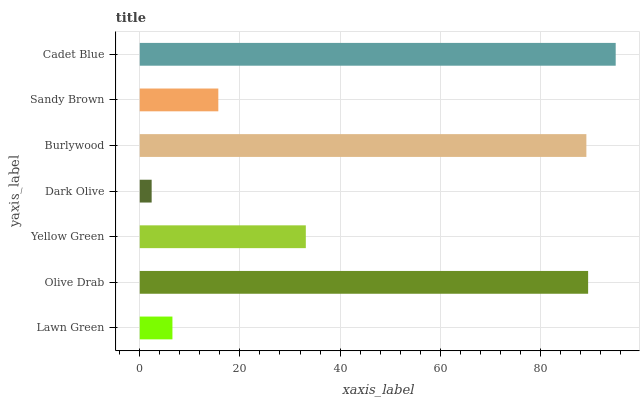Is Dark Olive the minimum?
Answer yes or no. Yes. Is Cadet Blue the maximum?
Answer yes or no. Yes. Is Olive Drab the minimum?
Answer yes or no. No. Is Olive Drab the maximum?
Answer yes or no. No. Is Olive Drab greater than Lawn Green?
Answer yes or no. Yes. Is Lawn Green less than Olive Drab?
Answer yes or no. Yes. Is Lawn Green greater than Olive Drab?
Answer yes or no. No. Is Olive Drab less than Lawn Green?
Answer yes or no. No. Is Yellow Green the high median?
Answer yes or no. Yes. Is Yellow Green the low median?
Answer yes or no. Yes. Is Olive Drab the high median?
Answer yes or no. No. Is Dark Olive the low median?
Answer yes or no. No. 